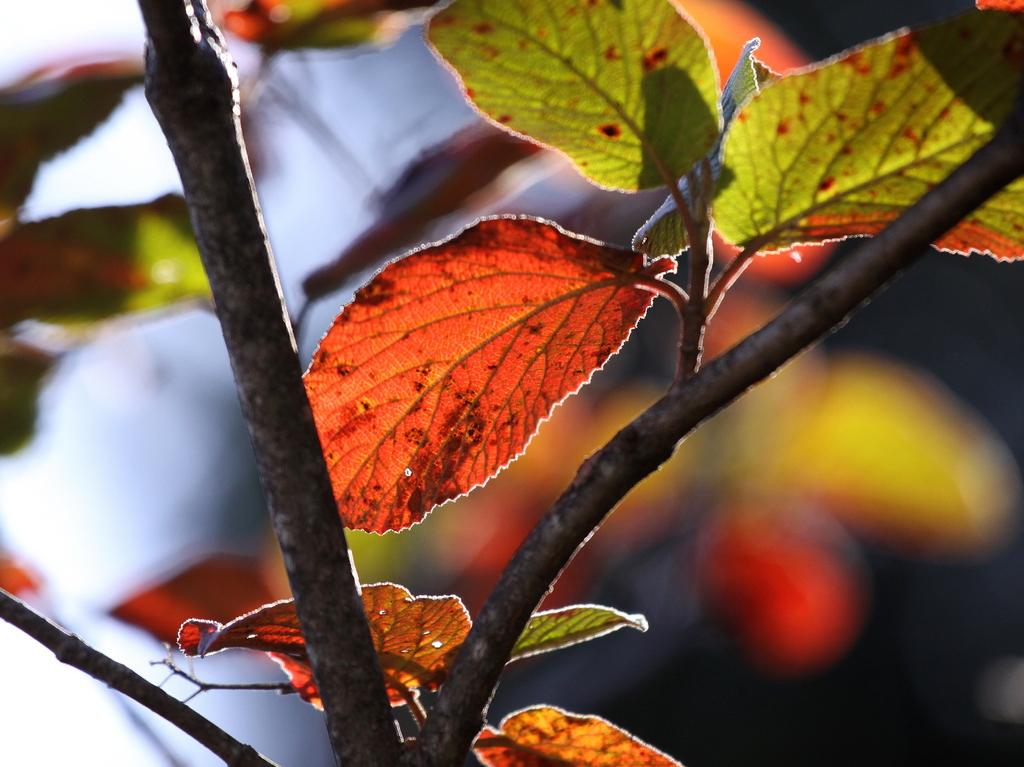What type of vegetation can be seen in the image? There are trees in the image. Can you determine the time of day the image was taken? The image was likely taken during the day, as there is sufficient light to see the trees. Is there any quicksand visible in the image? There is no quicksand present in the image. What type of heart can be seen in the image? There is no heart visible in the image; it features trees and no other living organisms. 